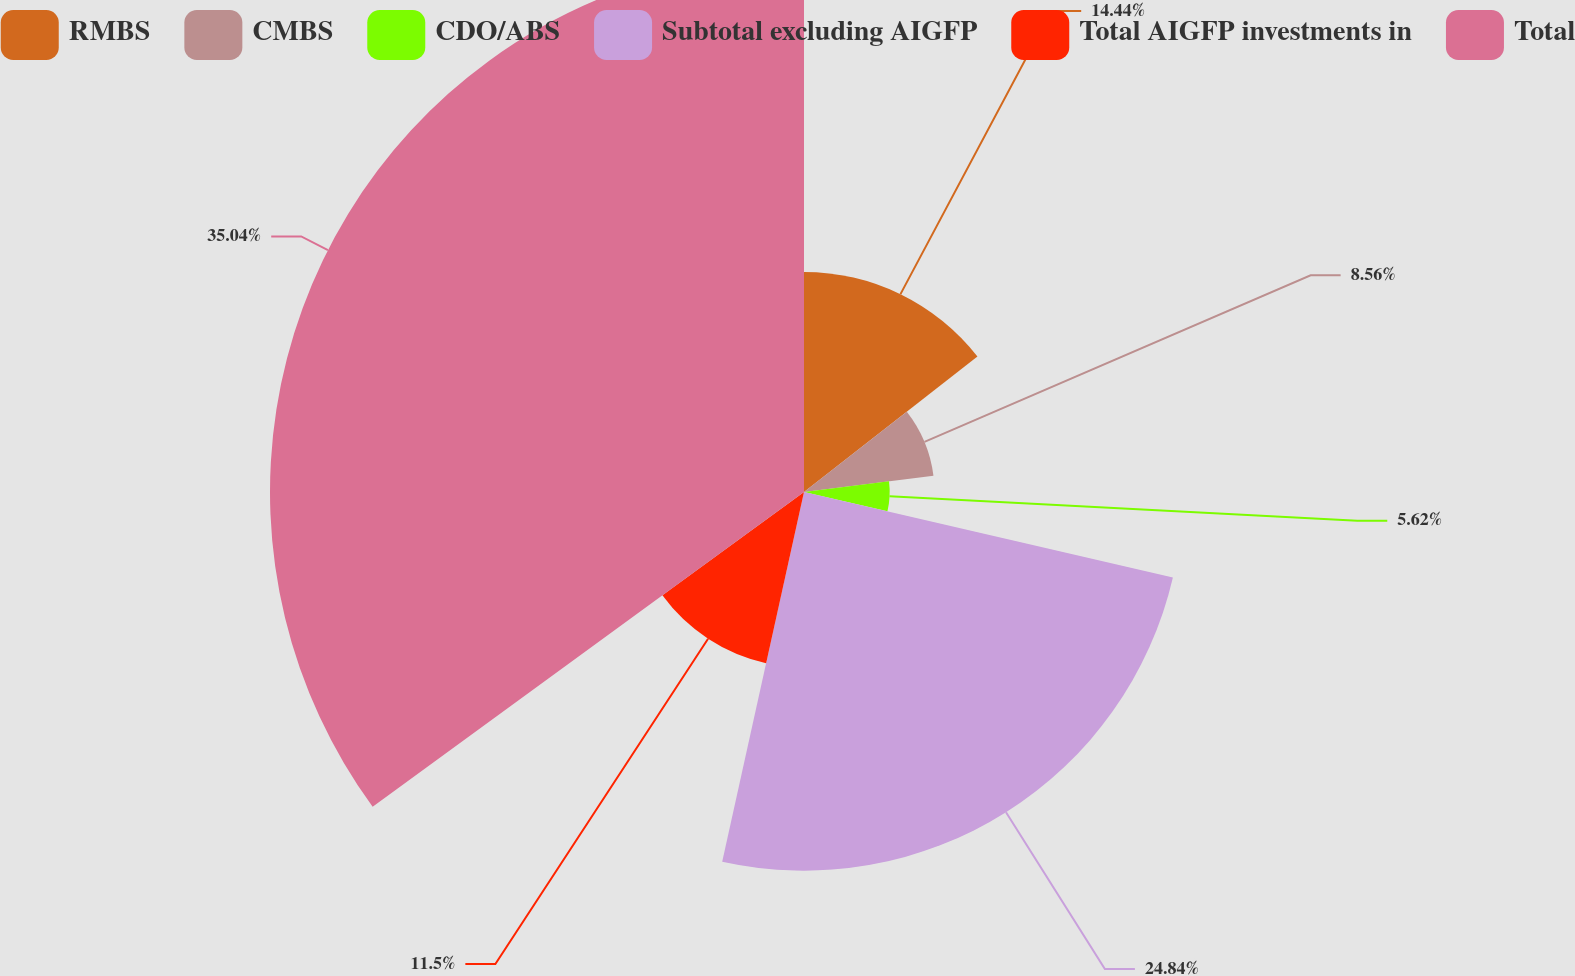Convert chart to OTSL. <chart><loc_0><loc_0><loc_500><loc_500><pie_chart><fcel>RMBS<fcel>CMBS<fcel>CDO/ABS<fcel>Subtotal excluding AIGFP<fcel>Total AIGFP investments in<fcel>Total<nl><fcel>14.44%<fcel>8.56%<fcel>5.62%<fcel>24.84%<fcel>11.5%<fcel>35.03%<nl></chart> 